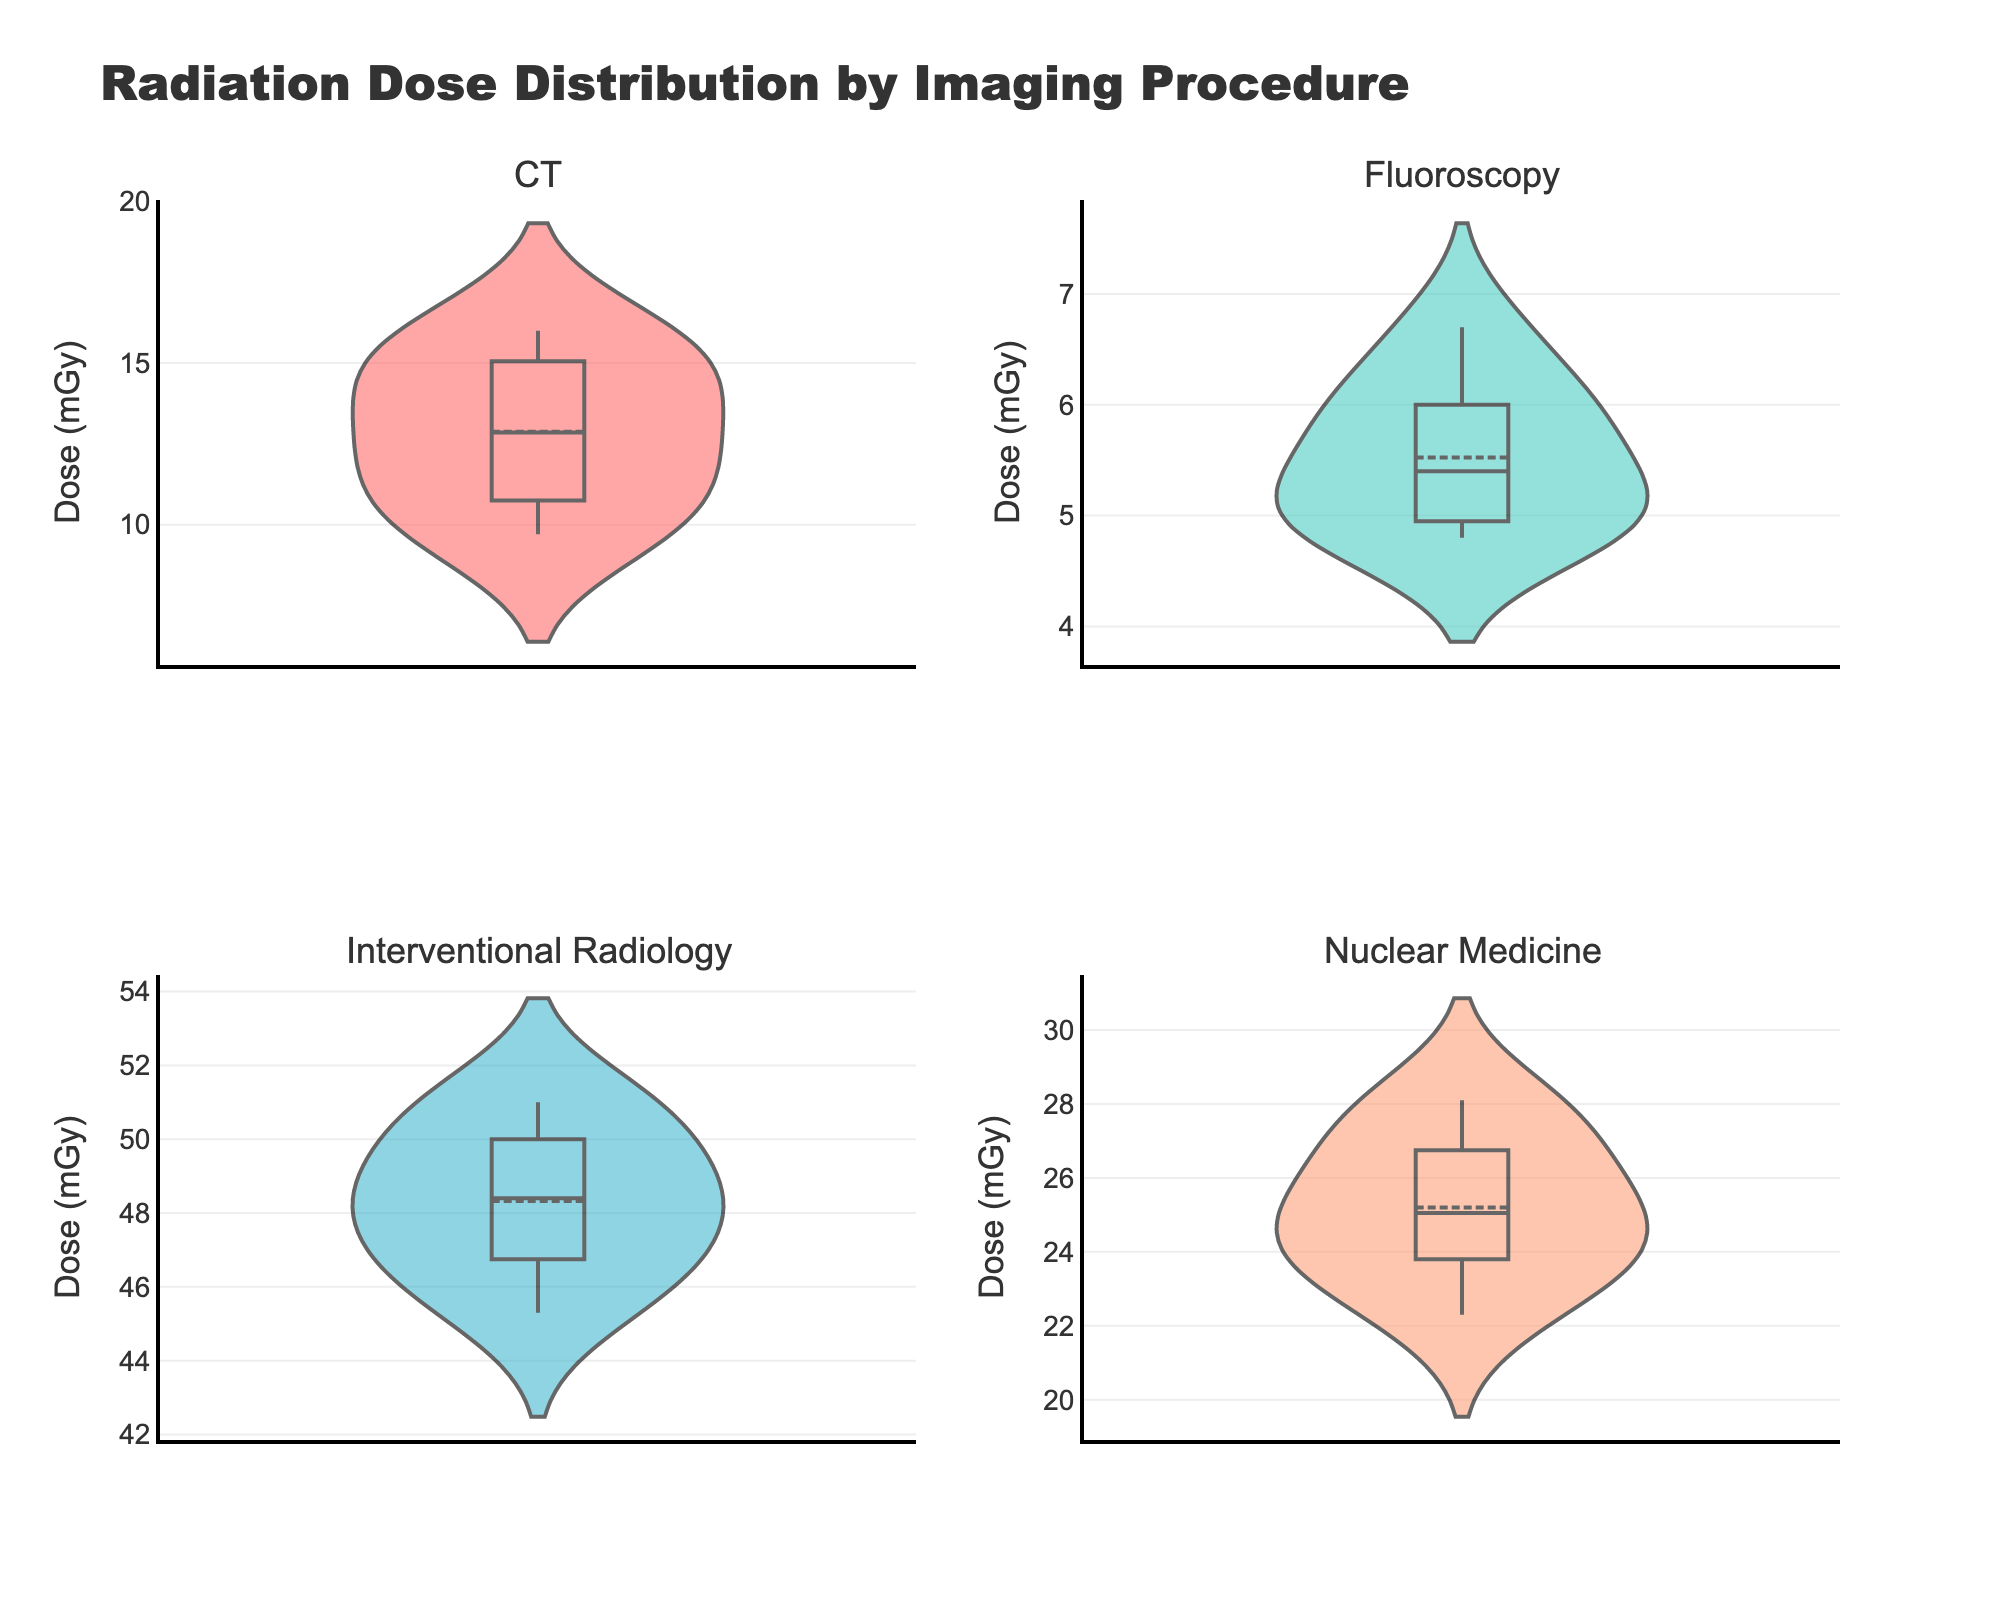What is the title of the figure? The title of the figure is displayed at the top and is usually the largest and most prominent text. Here, it reads "Radiation Dose Distribution by Imaging Procedure"
Answer: Radiation Dose Distribution by Imaging Procedure Which imaging procedure has the highest median radiation dose? In a violin plot, the median is indicated by the horizontal line inside the box. By visually comparing the median lines across all four procedures, Interventional Radiology has the highest median radiation dose.
Answer: Interventional Radiology What is the range of radiation doses observed in CT scans? The range can be determined by observing the highest and lowest points of the violin plot for CT. The highest dose is around 16.0 mGy, and the lowest dose is around 9.7 mGy. The range is calculated as 16.0 - 9.7.
Answer: 6.3 mGy How do the distributions of radiation doses compare between Fluoroscopy and Nuclear Medicine? By looking at the violin plots for Fluoroscopy and Nuclear Medicine, we can observe that Fluoroscopy has a narrower distribution with doses ranging approximately from 4.8 to 6.7 mGy, while Nuclear Medicine has a wider distribution with doses ranging approximately from 22.3 to 28.1 mGy. This indicates that Nuclear Medicine generally involves higher radiation doses and has more variation.
Answer: Nuclear Medicine has higher and more varied doses Which imaging procedure has the smallest interquartile range (IQR)? The IQR can be observed by the height of the box (middle 50% of the data) in the violin plot. Fluoroscopy has the smallest IQR as the box is very compact compared to those of other procedures.
Answer: Fluoroscopy What is the average radiation dose for Interventional Radiology? The average can be inferred from the mean line (usually a dotted or solid line) within the violin plot. For a precise answer, referring to the mean line inside the violin plot for Interventional Radiology is necessary. Based on the data, this seems to be around the mid-point of the range of values, approximately 48.3 mGy.
Answer: Approximately 48.3 mGy Which procedure shows the most skewed distribution? A skewed distribution would appear asymmetrical in the violin plot. Among the four procedures, Interventional Radiology appears to be the most skewed, with more data concentrated towards the lower end and a long tail towards higher doses.
Answer: Interventional Radiology Comparing CT and Nuclear Medicine, which has a higher mean radiation dose? The mean is indicated by a horizontal line inside the violin plot. By comparing the mean lines, it is clear that Nuclear Medicine has a higher mean radiation dose compared to CT.
Answer: Nuclear Medicine What is the maximum radiation dose observed in Nuclear Medicine? The maximum value is the top point of the violin plot for Nuclear Medicine, which is approximately 28.1 mGy.
Answer: 28.1 mGy What is the minimum radiation dose observed in Fluoroscopy? The minimum value is the bottom point of the violin plot for Fluoroscopy, which is approximately 4.8 mGy.
Answer: 4.8 mGy 